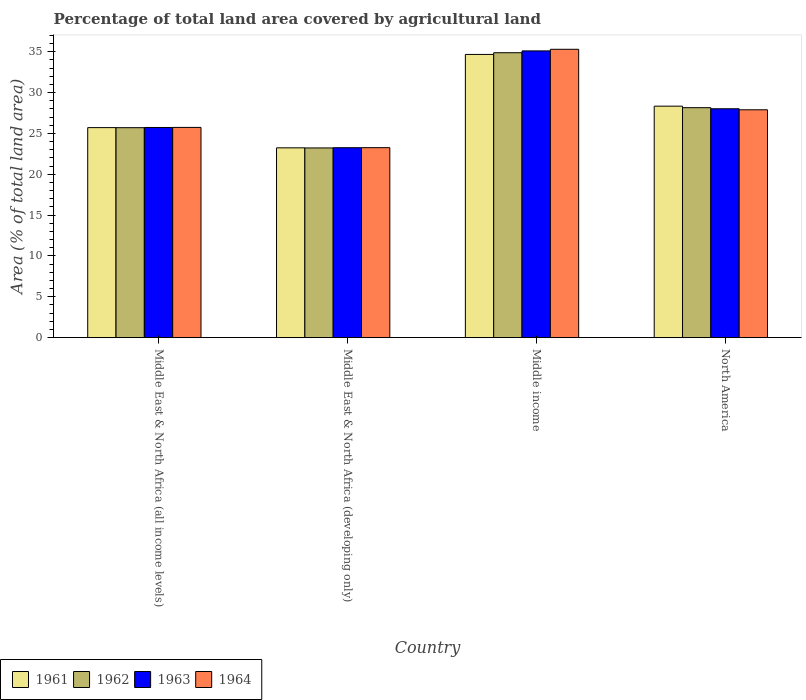How many different coloured bars are there?
Offer a terse response. 4. How many groups of bars are there?
Keep it short and to the point. 4. Are the number of bars per tick equal to the number of legend labels?
Offer a terse response. Yes. Are the number of bars on each tick of the X-axis equal?
Offer a terse response. Yes. What is the label of the 2nd group of bars from the left?
Offer a terse response. Middle East & North Africa (developing only). In how many cases, is the number of bars for a given country not equal to the number of legend labels?
Your response must be concise. 0. What is the percentage of agricultural land in 1963 in Middle East & North Africa (all income levels)?
Keep it short and to the point. 25.73. Across all countries, what is the maximum percentage of agricultural land in 1964?
Your answer should be compact. 35.31. Across all countries, what is the minimum percentage of agricultural land in 1963?
Provide a succinct answer. 23.26. In which country was the percentage of agricultural land in 1963 maximum?
Keep it short and to the point. Middle income. In which country was the percentage of agricultural land in 1962 minimum?
Keep it short and to the point. Middle East & North Africa (developing only). What is the total percentage of agricultural land in 1964 in the graph?
Provide a succinct answer. 112.21. What is the difference between the percentage of agricultural land in 1963 in Middle income and that in North America?
Keep it short and to the point. 7.08. What is the difference between the percentage of agricultural land in 1963 in Middle East & North Africa (developing only) and the percentage of agricultural land in 1961 in North America?
Offer a terse response. -5.09. What is the average percentage of agricultural land in 1964 per country?
Provide a short and direct response. 28.05. What is the difference between the percentage of agricultural land of/in 1963 and percentage of agricultural land of/in 1962 in North America?
Your answer should be compact. -0.13. What is the ratio of the percentage of agricultural land in 1961 in Middle income to that in North America?
Give a very brief answer. 1.22. Is the difference between the percentage of agricultural land in 1963 in Middle East & North Africa (all income levels) and North America greater than the difference between the percentage of agricultural land in 1962 in Middle East & North Africa (all income levels) and North America?
Provide a short and direct response. Yes. What is the difference between the highest and the second highest percentage of agricultural land in 1962?
Keep it short and to the point. -9.18. What is the difference between the highest and the lowest percentage of agricultural land in 1961?
Offer a terse response. 11.44. In how many countries, is the percentage of agricultural land in 1962 greater than the average percentage of agricultural land in 1962 taken over all countries?
Ensure brevity in your answer.  2. What does the 3rd bar from the left in Middle East & North Africa (developing only) represents?
Offer a very short reply. 1963. Is it the case that in every country, the sum of the percentage of agricultural land in 1963 and percentage of agricultural land in 1961 is greater than the percentage of agricultural land in 1964?
Make the answer very short. Yes. How many bars are there?
Your response must be concise. 16. How many countries are there in the graph?
Offer a terse response. 4. Are the values on the major ticks of Y-axis written in scientific E-notation?
Offer a terse response. No. Does the graph contain grids?
Provide a succinct answer. No. Where does the legend appear in the graph?
Provide a succinct answer. Bottom left. What is the title of the graph?
Your response must be concise. Percentage of total land area covered by agricultural land. Does "1976" appear as one of the legend labels in the graph?
Offer a very short reply. No. What is the label or title of the Y-axis?
Your answer should be compact. Area (% of total land area). What is the Area (% of total land area) in 1961 in Middle East & North Africa (all income levels)?
Make the answer very short. 25.72. What is the Area (% of total land area) of 1962 in Middle East & North Africa (all income levels)?
Offer a terse response. 25.71. What is the Area (% of total land area) in 1963 in Middle East & North Africa (all income levels)?
Keep it short and to the point. 25.73. What is the Area (% of total land area) in 1964 in Middle East & North Africa (all income levels)?
Give a very brief answer. 25.74. What is the Area (% of total land area) of 1961 in Middle East & North Africa (developing only)?
Give a very brief answer. 23.24. What is the Area (% of total land area) of 1962 in Middle East & North Africa (developing only)?
Ensure brevity in your answer.  23.23. What is the Area (% of total land area) of 1963 in Middle East & North Africa (developing only)?
Your response must be concise. 23.26. What is the Area (% of total land area) of 1964 in Middle East & North Africa (developing only)?
Your answer should be very brief. 23.26. What is the Area (% of total land area) of 1961 in Middle income?
Offer a terse response. 34.68. What is the Area (% of total land area) of 1962 in Middle income?
Give a very brief answer. 34.89. What is the Area (% of total land area) in 1963 in Middle income?
Provide a succinct answer. 35.11. What is the Area (% of total land area) of 1964 in Middle income?
Keep it short and to the point. 35.31. What is the Area (% of total land area) of 1961 in North America?
Your response must be concise. 28.34. What is the Area (% of total land area) in 1962 in North America?
Provide a short and direct response. 28.16. What is the Area (% of total land area) in 1963 in North America?
Provide a succinct answer. 28.02. What is the Area (% of total land area) in 1964 in North America?
Your answer should be very brief. 27.9. Across all countries, what is the maximum Area (% of total land area) in 1961?
Provide a short and direct response. 34.68. Across all countries, what is the maximum Area (% of total land area) in 1962?
Make the answer very short. 34.89. Across all countries, what is the maximum Area (% of total land area) in 1963?
Give a very brief answer. 35.11. Across all countries, what is the maximum Area (% of total land area) of 1964?
Your response must be concise. 35.31. Across all countries, what is the minimum Area (% of total land area) in 1961?
Your answer should be very brief. 23.24. Across all countries, what is the minimum Area (% of total land area) of 1962?
Your answer should be compact. 23.23. Across all countries, what is the minimum Area (% of total land area) in 1963?
Keep it short and to the point. 23.26. Across all countries, what is the minimum Area (% of total land area) of 1964?
Ensure brevity in your answer.  23.26. What is the total Area (% of total land area) of 1961 in the graph?
Keep it short and to the point. 111.98. What is the total Area (% of total land area) of 1962 in the graph?
Keep it short and to the point. 111.98. What is the total Area (% of total land area) in 1963 in the graph?
Provide a short and direct response. 112.13. What is the total Area (% of total land area) of 1964 in the graph?
Offer a terse response. 112.21. What is the difference between the Area (% of total land area) in 1961 in Middle East & North Africa (all income levels) and that in Middle East & North Africa (developing only)?
Your answer should be very brief. 2.48. What is the difference between the Area (% of total land area) of 1962 in Middle East & North Africa (all income levels) and that in Middle East & North Africa (developing only)?
Your response must be concise. 2.48. What is the difference between the Area (% of total land area) in 1963 in Middle East & North Africa (all income levels) and that in Middle East & North Africa (developing only)?
Offer a very short reply. 2.48. What is the difference between the Area (% of total land area) in 1964 in Middle East & North Africa (all income levels) and that in Middle East & North Africa (developing only)?
Give a very brief answer. 2.48. What is the difference between the Area (% of total land area) in 1961 in Middle East & North Africa (all income levels) and that in Middle income?
Your answer should be very brief. -8.96. What is the difference between the Area (% of total land area) in 1962 in Middle East & North Africa (all income levels) and that in Middle income?
Your response must be concise. -9.18. What is the difference between the Area (% of total land area) in 1963 in Middle East & North Africa (all income levels) and that in Middle income?
Keep it short and to the point. -9.38. What is the difference between the Area (% of total land area) of 1964 in Middle East & North Africa (all income levels) and that in Middle income?
Your answer should be compact. -9.56. What is the difference between the Area (% of total land area) in 1961 in Middle East & North Africa (all income levels) and that in North America?
Your answer should be compact. -2.63. What is the difference between the Area (% of total land area) of 1962 in Middle East & North Africa (all income levels) and that in North America?
Offer a terse response. -2.45. What is the difference between the Area (% of total land area) in 1963 in Middle East & North Africa (all income levels) and that in North America?
Provide a short and direct response. -2.29. What is the difference between the Area (% of total land area) of 1964 in Middle East & North Africa (all income levels) and that in North America?
Make the answer very short. -2.16. What is the difference between the Area (% of total land area) in 1961 in Middle East & North Africa (developing only) and that in Middle income?
Your answer should be compact. -11.44. What is the difference between the Area (% of total land area) in 1962 in Middle East & North Africa (developing only) and that in Middle income?
Give a very brief answer. -11.66. What is the difference between the Area (% of total land area) of 1963 in Middle East & North Africa (developing only) and that in Middle income?
Provide a succinct answer. -11.85. What is the difference between the Area (% of total land area) in 1964 in Middle East & North Africa (developing only) and that in Middle income?
Offer a terse response. -12.04. What is the difference between the Area (% of total land area) of 1961 in Middle East & North Africa (developing only) and that in North America?
Ensure brevity in your answer.  -5.1. What is the difference between the Area (% of total land area) in 1962 in Middle East & North Africa (developing only) and that in North America?
Your response must be concise. -4.93. What is the difference between the Area (% of total land area) of 1963 in Middle East & North Africa (developing only) and that in North America?
Provide a short and direct response. -4.77. What is the difference between the Area (% of total land area) in 1964 in Middle East & North Africa (developing only) and that in North America?
Your answer should be compact. -4.64. What is the difference between the Area (% of total land area) in 1961 in Middle income and that in North America?
Make the answer very short. 6.33. What is the difference between the Area (% of total land area) of 1962 in Middle income and that in North America?
Ensure brevity in your answer.  6.73. What is the difference between the Area (% of total land area) of 1963 in Middle income and that in North America?
Provide a short and direct response. 7.08. What is the difference between the Area (% of total land area) of 1964 in Middle income and that in North America?
Ensure brevity in your answer.  7.41. What is the difference between the Area (% of total land area) in 1961 in Middle East & North Africa (all income levels) and the Area (% of total land area) in 1962 in Middle East & North Africa (developing only)?
Offer a very short reply. 2.49. What is the difference between the Area (% of total land area) of 1961 in Middle East & North Africa (all income levels) and the Area (% of total land area) of 1963 in Middle East & North Africa (developing only)?
Your answer should be very brief. 2.46. What is the difference between the Area (% of total land area) in 1961 in Middle East & North Africa (all income levels) and the Area (% of total land area) in 1964 in Middle East & North Africa (developing only)?
Your answer should be very brief. 2.45. What is the difference between the Area (% of total land area) in 1962 in Middle East & North Africa (all income levels) and the Area (% of total land area) in 1963 in Middle East & North Africa (developing only)?
Your answer should be compact. 2.45. What is the difference between the Area (% of total land area) of 1962 in Middle East & North Africa (all income levels) and the Area (% of total land area) of 1964 in Middle East & North Africa (developing only)?
Keep it short and to the point. 2.45. What is the difference between the Area (% of total land area) in 1963 in Middle East & North Africa (all income levels) and the Area (% of total land area) in 1964 in Middle East & North Africa (developing only)?
Provide a succinct answer. 2.47. What is the difference between the Area (% of total land area) of 1961 in Middle East & North Africa (all income levels) and the Area (% of total land area) of 1962 in Middle income?
Keep it short and to the point. -9.17. What is the difference between the Area (% of total land area) in 1961 in Middle East & North Africa (all income levels) and the Area (% of total land area) in 1963 in Middle income?
Offer a very short reply. -9.39. What is the difference between the Area (% of total land area) in 1961 in Middle East & North Africa (all income levels) and the Area (% of total land area) in 1964 in Middle income?
Keep it short and to the point. -9.59. What is the difference between the Area (% of total land area) of 1962 in Middle East & North Africa (all income levels) and the Area (% of total land area) of 1963 in Middle income?
Give a very brief answer. -9.4. What is the difference between the Area (% of total land area) in 1962 in Middle East & North Africa (all income levels) and the Area (% of total land area) in 1964 in Middle income?
Offer a terse response. -9.6. What is the difference between the Area (% of total land area) in 1963 in Middle East & North Africa (all income levels) and the Area (% of total land area) in 1964 in Middle income?
Ensure brevity in your answer.  -9.57. What is the difference between the Area (% of total land area) of 1961 in Middle East & North Africa (all income levels) and the Area (% of total land area) of 1962 in North America?
Offer a terse response. -2.44. What is the difference between the Area (% of total land area) in 1961 in Middle East & North Africa (all income levels) and the Area (% of total land area) in 1963 in North America?
Offer a very short reply. -2.31. What is the difference between the Area (% of total land area) of 1961 in Middle East & North Africa (all income levels) and the Area (% of total land area) of 1964 in North America?
Your response must be concise. -2.18. What is the difference between the Area (% of total land area) in 1962 in Middle East & North Africa (all income levels) and the Area (% of total land area) in 1963 in North America?
Keep it short and to the point. -2.32. What is the difference between the Area (% of total land area) in 1962 in Middle East & North Africa (all income levels) and the Area (% of total land area) in 1964 in North America?
Provide a succinct answer. -2.19. What is the difference between the Area (% of total land area) of 1963 in Middle East & North Africa (all income levels) and the Area (% of total land area) of 1964 in North America?
Give a very brief answer. -2.16. What is the difference between the Area (% of total land area) of 1961 in Middle East & North Africa (developing only) and the Area (% of total land area) of 1962 in Middle income?
Ensure brevity in your answer.  -11.65. What is the difference between the Area (% of total land area) in 1961 in Middle East & North Africa (developing only) and the Area (% of total land area) in 1963 in Middle income?
Ensure brevity in your answer.  -11.87. What is the difference between the Area (% of total land area) in 1961 in Middle East & North Africa (developing only) and the Area (% of total land area) in 1964 in Middle income?
Provide a succinct answer. -12.06. What is the difference between the Area (% of total land area) in 1962 in Middle East & North Africa (developing only) and the Area (% of total land area) in 1963 in Middle income?
Make the answer very short. -11.88. What is the difference between the Area (% of total land area) in 1962 in Middle East & North Africa (developing only) and the Area (% of total land area) in 1964 in Middle income?
Keep it short and to the point. -12.08. What is the difference between the Area (% of total land area) in 1963 in Middle East & North Africa (developing only) and the Area (% of total land area) in 1964 in Middle income?
Offer a very short reply. -12.05. What is the difference between the Area (% of total land area) in 1961 in Middle East & North Africa (developing only) and the Area (% of total land area) in 1962 in North America?
Your answer should be compact. -4.92. What is the difference between the Area (% of total land area) in 1961 in Middle East & North Africa (developing only) and the Area (% of total land area) in 1963 in North America?
Ensure brevity in your answer.  -4.78. What is the difference between the Area (% of total land area) in 1961 in Middle East & North Africa (developing only) and the Area (% of total land area) in 1964 in North America?
Keep it short and to the point. -4.66. What is the difference between the Area (% of total land area) in 1962 in Middle East & North Africa (developing only) and the Area (% of total land area) in 1963 in North America?
Offer a terse response. -4.8. What is the difference between the Area (% of total land area) of 1962 in Middle East & North Africa (developing only) and the Area (% of total land area) of 1964 in North America?
Your answer should be compact. -4.67. What is the difference between the Area (% of total land area) of 1963 in Middle East & North Africa (developing only) and the Area (% of total land area) of 1964 in North America?
Your answer should be compact. -4.64. What is the difference between the Area (% of total land area) of 1961 in Middle income and the Area (% of total land area) of 1962 in North America?
Make the answer very short. 6.52. What is the difference between the Area (% of total land area) of 1961 in Middle income and the Area (% of total land area) of 1963 in North America?
Your answer should be very brief. 6.65. What is the difference between the Area (% of total land area) in 1961 in Middle income and the Area (% of total land area) in 1964 in North America?
Ensure brevity in your answer.  6.78. What is the difference between the Area (% of total land area) of 1962 in Middle income and the Area (% of total land area) of 1963 in North America?
Your answer should be compact. 6.86. What is the difference between the Area (% of total land area) in 1962 in Middle income and the Area (% of total land area) in 1964 in North America?
Provide a short and direct response. 6.99. What is the difference between the Area (% of total land area) in 1963 in Middle income and the Area (% of total land area) in 1964 in North America?
Your answer should be very brief. 7.21. What is the average Area (% of total land area) in 1961 per country?
Give a very brief answer. 27.99. What is the average Area (% of total land area) in 1962 per country?
Give a very brief answer. 28. What is the average Area (% of total land area) in 1963 per country?
Provide a succinct answer. 28.03. What is the average Area (% of total land area) of 1964 per country?
Your answer should be very brief. 28.05. What is the difference between the Area (% of total land area) of 1961 and Area (% of total land area) of 1962 in Middle East & North Africa (all income levels)?
Your answer should be compact. 0.01. What is the difference between the Area (% of total land area) of 1961 and Area (% of total land area) of 1963 in Middle East & North Africa (all income levels)?
Keep it short and to the point. -0.02. What is the difference between the Area (% of total land area) in 1961 and Area (% of total land area) in 1964 in Middle East & North Africa (all income levels)?
Your response must be concise. -0.02. What is the difference between the Area (% of total land area) of 1962 and Area (% of total land area) of 1963 in Middle East & North Africa (all income levels)?
Your response must be concise. -0.03. What is the difference between the Area (% of total land area) in 1962 and Area (% of total land area) in 1964 in Middle East & North Africa (all income levels)?
Give a very brief answer. -0.03. What is the difference between the Area (% of total land area) in 1963 and Area (% of total land area) in 1964 in Middle East & North Africa (all income levels)?
Offer a very short reply. -0.01. What is the difference between the Area (% of total land area) of 1961 and Area (% of total land area) of 1962 in Middle East & North Africa (developing only)?
Provide a succinct answer. 0.01. What is the difference between the Area (% of total land area) in 1961 and Area (% of total land area) in 1963 in Middle East & North Africa (developing only)?
Your answer should be very brief. -0.02. What is the difference between the Area (% of total land area) of 1961 and Area (% of total land area) of 1964 in Middle East & North Africa (developing only)?
Provide a succinct answer. -0.02. What is the difference between the Area (% of total land area) in 1962 and Area (% of total land area) in 1963 in Middle East & North Africa (developing only)?
Your answer should be very brief. -0.03. What is the difference between the Area (% of total land area) in 1962 and Area (% of total land area) in 1964 in Middle East & North Africa (developing only)?
Offer a very short reply. -0.03. What is the difference between the Area (% of total land area) of 1963 and Area (% of total land area) of 1964 in Middle East & North Africa (developing only)?
Offer a terse response. -0.01. What is the difference between the Area (% of total land area) in 1961 and Area (% of total land area) in 1962 in Middle income?
Give a very brief answer. -0.21. What is the difference between the Area (% of total land area) of 1961 and Area (% of total land area) of 1963 in Middle income?
Your response must be concise. -0.43. What is the difference between the Area (% of total land area) in 1961 and Area (% of total land area) in 1964 in Middle income?
Keep it short and to the point. -0.63. What is the difference between the Area (% of total land area) of 1962 and Area (% of total land area) of 1963 in Middle income?
Your answer should be very brief. -0.22. What is the difference between the Area (% of total land area) in 1962 and Area (% of total land area) in 1964 in Middle income?
Your answer should be compact. -0.42. What is the difference between the Area (% of total land area) in 1963 and Area (% of total land area) in 1964 in Middle income?
Provide a short and direct response. -0.2. What is the difference between the Area (% of total land area) in 1961 and Area (% of total land area) in 1962 in North America?
Offer a very short reply. 0.19. What is the difference between the Area (% of total land area) of 1961 and Area (% of total land area) of 1963 in North America?
Keep it short and to the point. 0.32. What is the difference between the Area (% of total land area) of 1961 and Area (% of total land area) of 1964 in North America?
Your response must be concise. 0.44. What is the difference between the Area (% of total land area) in 1962 and Area (% of total land area) in 1963 in North America?
Your answer should be very brief. 0.13. What is the difference between the Area (% of total land area) in 1962 and Area (% of total land area) in 1964 in North America?
Your response must be concise. 0.26. What is the difference between the Area (% of total land area) in 1963 and Area (% of total land area) in 1964 in North America?
Provide a succinct answer. 0.13. What is the ratio of the Area (% of total land area) of 1961 in Middle East & North Africa (all income levels) to that in Middle East & North Africa (developing only)?
Your answer should be compact. 1.11. What is the ratio of the Area (% of total land area) in 1962 in Middle East & North Africa (all income levels) to that in Middle East & North Africa (developing only)?
Give a very brief answer. 1.11. What is the ratio of the Area (% of total land area) in 1963 in Middle East & North Africa (all income levels) to that in Middle East & North Africa (developing only)?
Provide a short and direct response. 1.11. What is the ratio of the Area (% of total land area) of 1964 in Middle East & North Africa (all income levels) to that in Middle East & North Africa (developing only)?
Your response must be concise. 1.11. What is the ratio of the Area (% of total land area) of 1961 in Middle East & North Africa (all income levels) to that in Middle income?
Your response must be concise. 0.74. What is the ratio of the Area (% of total land area) in 1962 in Middle East & North Africa (all income levels) to that in Middle income?
Provide a succinct answer. 0.74. What is the ratio of the Area (% of total land area) of 1963 in Middle East & North Africa (all income levels) to that in Middle income?
Offer a very short reply. 0.73. What is the ratio of the Area (% of total land area) in 1964 in Middle East & North Africa (all income levels) to that in Middle income?
Offer a very short reply. 0.73. What is the ratio of the Area (% of total land area) of 1961 in Middle East & North Africa (all income levels) to that in North America?
Offer a terse response. 0.91. What is the ratio of the Area (% of total land area) in 1962 in Middle East & North Africa (all income levels) to that in North America?
Your answer should be very brief. 0.91. What is the ratio of the Area (% of total land area) of 1963 in Middle East & North Africa (all income levels) to that in North America?
Provide a short and direct response. 0.92. What is the ratio of the Area (% of total land area) in 1964 in Middle East & North Africa (all income levels) to that in North America?
Your response must be concise. 0.92. What is the ratio of the Area (% of total land area) of 1961 in Middle East & North Africa (developing only) to that in Middle income?
Keep it short and to the point. 0.67. What is the ratio of the Area (% of total land area) in 1962 in Middle East & North Africa (developing only) to that in Middle income?
Keep it short and to the point. 0.67. What is the ratio of the Area (% of total land area) in 1963 in Middle East & North Africa (developing only) to that in Middle income?
Provide a succinct answer. 0.66. What is the ratio of the Area (% of total land area) of 1964 in Middle East & North Africa (developing only) to that in Middle income?
Your answer should be compact. 0.66. What is the ratio of the Area (% of total land area) of 1961 in Middle East & North Africa (developing only) to that in North America?
Provide a short and direct response. 0.82. What is the ratio of the Area (% of total land area) of 1962 in Middle East & North Africa (developing only) to that in North America?
Provide a succinct answer. 0.82. What is the ratio of the Area (% of total land area) in 1963 in Middle East & North Africa (developing only) to that in North America?
Offer a very short reply. 0.83. What is the ratio of the Area (% of total land area) in 1964 in Middle East & North Africa (developing only) to that in North America?
Make the answer very short. 0.83. What is the ratio of the Area (% of total land area) in 1961 in Middle income to that in North America?
Ensure brevity in your answer.  1.22. What is the ratio of the Area (% of total land area) of 1962 in Middle income to that in North America?
Give a very brief answer. 1.24. What is the ratio of the Area (% of total land area) of 1963 in Middle income to that in North America?
Offer a very short reply. 1.25. What is the ratio of the Area (% of total land area) in 1964 in Middle income to that in North America?
Make the answer very short. 1.27. What is the difference between the highest and the second highest Area (% of total land area) in 1961?
Ensure brevity in your answer.  6.33. What is the difference between the highest and the second highest Area (% of total land area) in 1962?
Your answer should be very brief. 6.73. What is the difference between the highest and the second highest Area (% of total land area) of 1963?
Give a very brief answer. 7.08. What is the difference between the highest and the second highest Area (% of total land area) in 1964?
Give a very brief answer. 7.41. What is the difference between the highest and the lowest Area (% of total land area) of 1961?
Your answer should be very brief. 11.44. What is the difference between the highest and the lowest Area (% of total land area) of 1962?
Keep it short and to the point. 11.66. What is the difference between the highest and the lowest Area (% of total land area) of 1963?
Provide a short and direct response. 11.85. What is the difference between the highest and the lowest Area (% of total land area) in 1964?
Offer a very short reply. 12.04. 